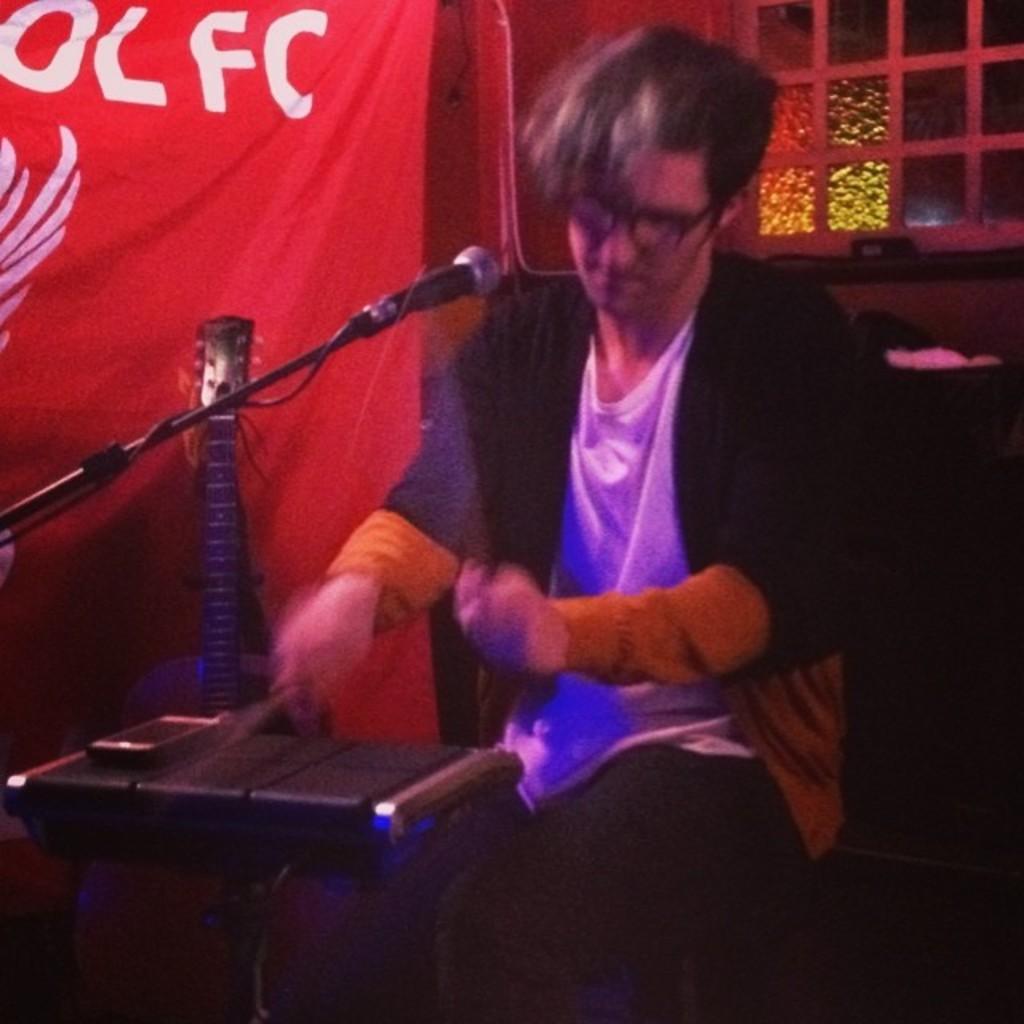Describe this image in one or two sentences. In this picture we can see a person playing playing drums. Towards left there is a guitar and there is a mic also. In the background we can see curtain and window. 